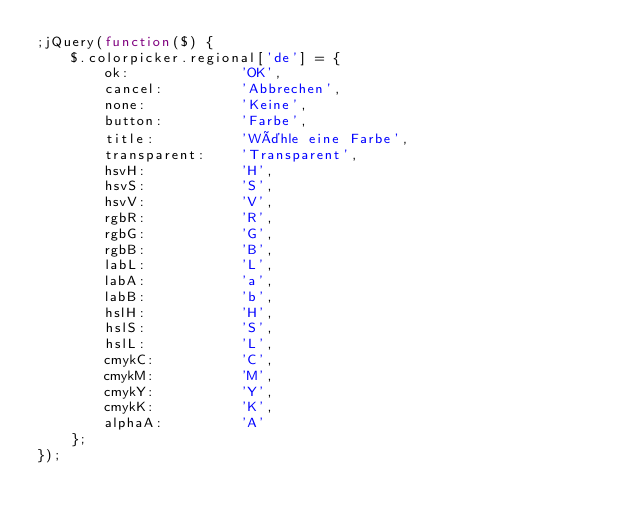<code> <loc_0><loc_0><loc_500><loc_500><_JavaScript_>;jQuery(function($) {
	$.colorpicker.regional['de'] = {
		ok:				'OK',
		cancel:			'Abbrechen',
		none:			'Keine',
		button:			'Farbe',
		title:			'Wähle eine Farbe',
		transparent:	'Transparent',
		hsvH:			'H',
		hsvS:			'S',
		hsvV:			'V',
		rgbR:			'R',
		rgbG:			'G',
		rgbB:			'B',
		labL:			'L',
		labA:			'a',
		labB:			'b',
		hslH:			'H',
		hslS:			'S',
		hslL:			'L',
		cmykC:			'C',
		cmykM:			'M',
		cmykY:			'Y',
		cmykK:			'K',
		alphaA:			'A'
	};
});</code> 